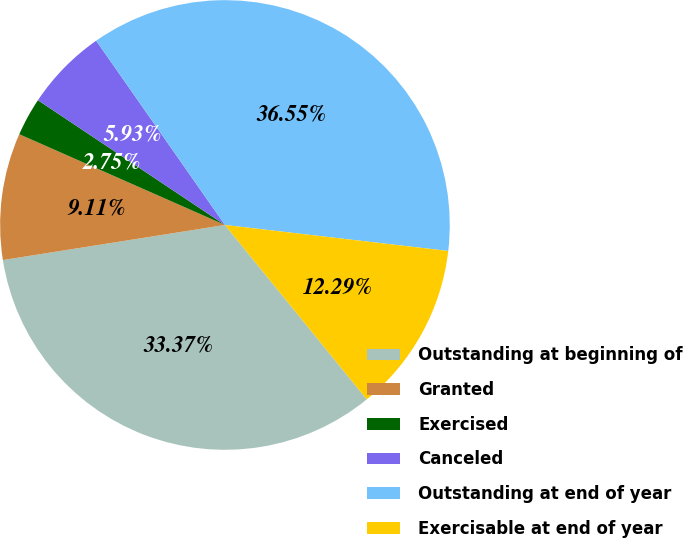Convert chart to OTSL. <chart><loc_0><loc_0><loc_500><loc_500><pie_chart><fcel>Outstanding at beginning of<fcel>Granted<fcel>Exercised<fcel>Canceled<fcel>Outstanding at end of year<fcel>Exercisable at end of year<nl><fcel>33.38%<fcel>9.11%<fcel>2.75%<fcel>5.93%<fcel>36.56%<fcel>12.29%<nl></chart> 